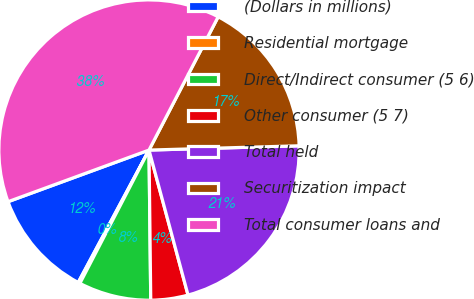<chart> <loc_0><loc_0><loc_500><loc_500><pie_chart><fcel>(Dollars in millions)<fcel>Residential mortgage<fcel>Direct/Indirect consumer (5 6)<fcel>Other consumer (5 7)<fcel>Total held<fcel>Securitization impact<fcel>Total consumer loans and<nl><fcel>11.6%<fcel>0.2%<fcel>7.8%<fcel>4.0%<fcel>21.27%<fcel>16.93%<fcel>38.21%<nl></chart> 